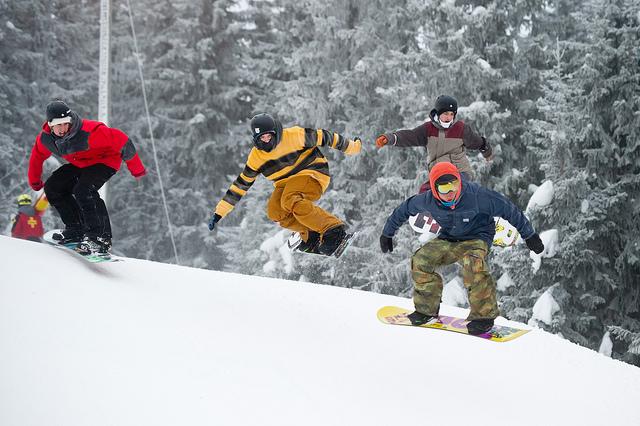How high do they jump?
Give a very brief answer. Not high. How many people are jumping?
Give a very brief answer. 2. Are these people snowboarding?
Short answer required. Yes. 